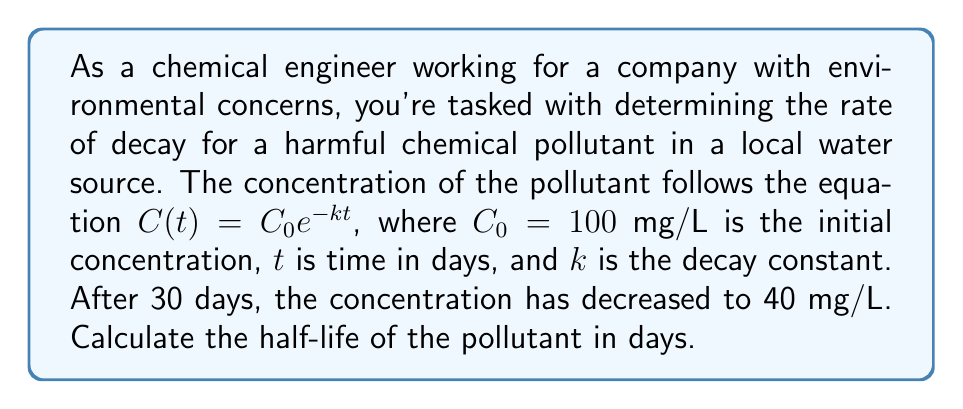Give your solution to this math problem. 1) We start with the equation for exponential decay:
   $$C(t) = C_0e^{-kt}$$

2) We know that $C_0 = 100$ mg/L, $t = 30$ days, and $C(30) = 40$ mg/L. Let's substitute these values:
   $$40 = 100e^{-30k}$$

3) Divide both sides by 100:
   $$0.4 = e^{-30k}$$

4) Take the natural logarithm of both sides:
   $$\ln(0.4) = -30k$$

5) Solve for $k$:
   $$k = -\frac{\ln(0.4)}{30} \approx 0.0304$$

6) Now that we have $k$, we can calculate the half-life. The half-life is the time it takes for the concentration to reduce to half its original value. Let's call this time $t_{1/2}$. We can write:
   $$\frac{C_0}{2} = C_0e^{-kt_{1/2}}$$

7) The $C_0$ cancels out:
   $$\frac{1}{2} = e^{-kt_{1/2}}$$

8) Take the natural logarithm of both sides:
   $$\ln(\frac{1}{2}) = -kt_{1/2}$$

9) Solve for $t_{1/2}$:
   $$t_{1/2} = -\frac{\ln(\frac{1}{2})}{k} = \frac{\ln(2)}{k}$$

10) Substitute the value of $k$ we found earlier:
    $$t_{1/2} = \frac{\ln(2)}{0.0304} \approx 22.8$$

Therefore, the half-life of the pollutant is approximately 22.8 days.
Answer: 22.8 days 